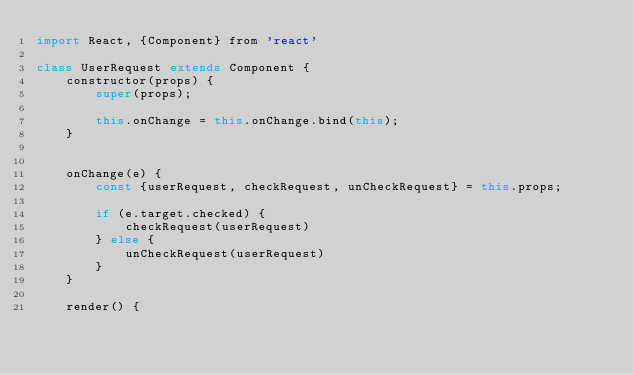<code> <loc_0><loc_0><loc_500><loc_500><_JavaScript_>import React, {Component} from 'react'

class UserRequest extends Component {
    constructor(props) {
        super(props);

        this.onChange = this.onChange.bind(this);
    }


    onChange(e) {
        const {userRequest, checkRequest, unCheckRequest} = this.props;

        if (e.target.checked) {
            checkRequest(userRequest)
        } else {
            unCheckRequest(userRequest)
        }
    }

    render() {</code> 